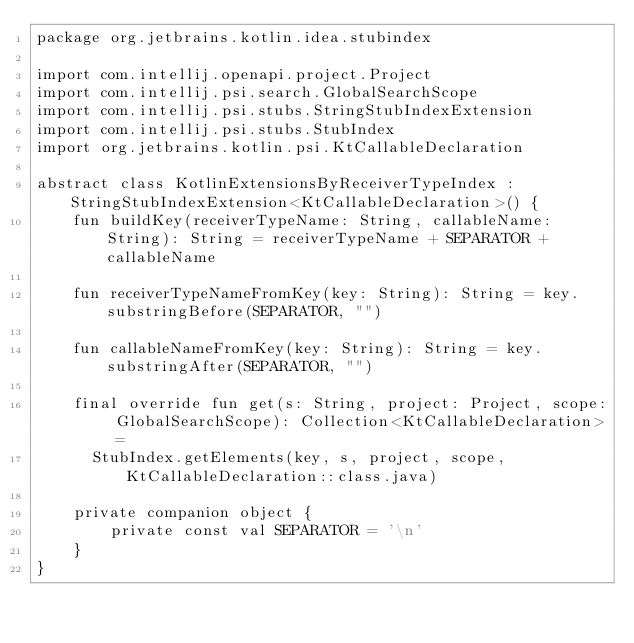<code> <loc_0><loc_0><loc_500><loc_500><_Kotlin_>package org.jetbrains.kotlin.idea.stubindex

import com.intellij.openapi.project.Project
import com.intellij.psi.search.GlobalSearchScope
import com.intellij.psi.stubs.StringStubIndexExtension
import com.intellij.psi.stubs.StubIndex
import org.jetbrains.kotlin.psi.KtCallableDeclaration

abstract class KotlinExtensionsByReceiverTypeIndex : StringStubIndexExtension<KtCallableDeclaration>() {
    fun buildKey(receiverTypeName: String, callableName: String): String = receiverTypeName + SEPARATOR + callableName

    fun receiverTypeNameFromKey(key: String): String = key.substringBefore(SEPARATOR, "")

    fun callableNameFromKey(key: String): String = key.substringAfter(SEPARATOR, "")

    final override fun get(s: String, project: Project, scope: GlobalSearchScope): Collection<KtCallableDeclaration> =
      StubIndex.getElements(key, s, project, scope, KtCallableDeclaration::class.java)

    private companion object {
        private const val SEPARATOR = '\n'
    }
}</code> 